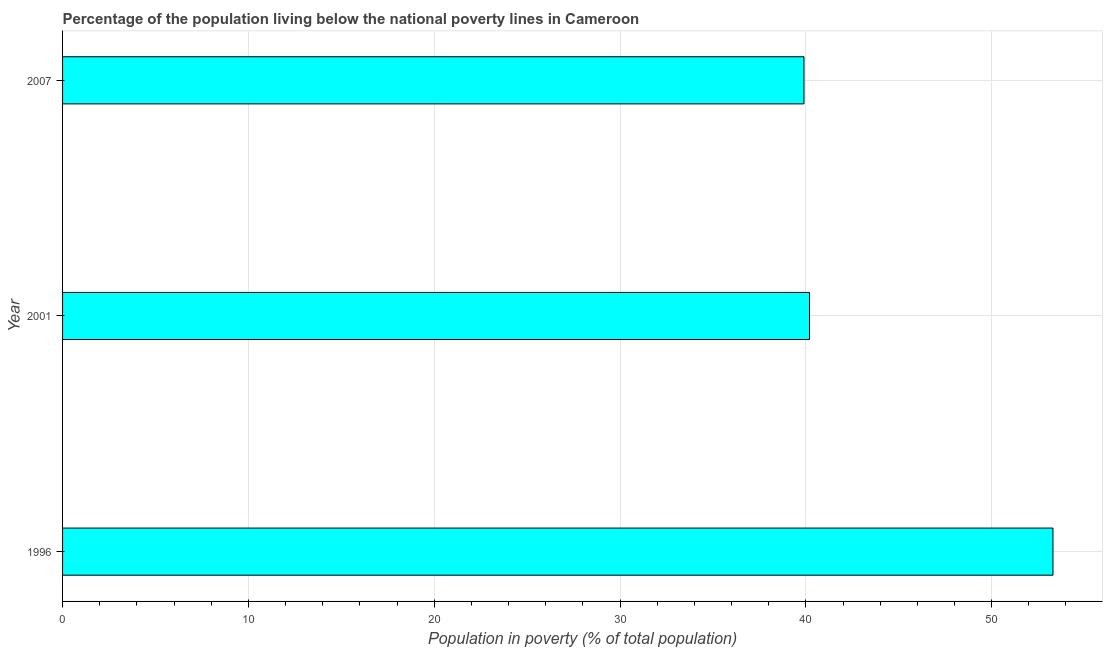Does the graph contain grids?
Offer a terse response. Yes. What is the title of the graph?
Give a very brief answer. Percentage of the population living below the national poverty lines in Cameroon. What is the label or title of the X-axis?
Provide a succinct answer. Population in poverty (% of total population). What is the label or title of the Y-axis?
Your answer should be very brief. Year. What is the percentage of population living below poverty line in 1996?
Your response must be concise. 53.3. Across all years, what is the maximum percentage of population living below poverty line?
Your answer should be very brief. 53.3. Across all years, what is the minimum percentage of population living below poverty line?
Keep it short and to the point. 39.9. In which year was the percentage of population living below poverty line minimum?
Make the answer very short. 2007. What is the sum of the percentage of population living below poverty line?
Give a very brief answer. 133.4. What is the average percentage of population living below poverty line per year?
Offer a terse response. 44.47. What is the median percentage of population living below poverty line?
Your response must be concise. 40.2. In how many years, is the percentage of population living below poverty line greater than 40 %?
Provide a succinct answer. 2. Do a majority of the years between 2001 and 2007 (inclusive) have percentage of population living below poverty line greater than 44 %?
Keep it short and to the point. No. Is the difference between the percentage of population living below poverty line in 2001 and 2007 greater than the difference between any two years?
Give a very brief answer. No. What is the difference between the highest and the second highest percentage of population living below poverty line?
Offer a very short reply. 13.1. Is the sum of the percentage of population living below poverty line in 1996 and 2007 greater than the maximum percentage of population living below poverty line across all years?
Keep it short and to the point. Yes. What is the difference between the highest and the lowest percentage of population living below poverty line?
Your answer should be compact. 13.4. In how many years, is the percentage of population living below poverty line greater than the average percentage of population living below poverty line taken over all years?
Provide a short and direct response. 1. How many years are there in the graph?
Provide a succinct answer. 3. What is the difference between two consecutive major ticks on the X-axis?
Make the answer very short. 10. Are the values on the major ticks of X-axis written in scientific E-notation?
Keep it short and to the point. No. What is the Population in poverty (% of total population) in 1996?
Your response must be concise. 53.3. What is the Population in poverty (% of total population) of 2001?
Keep it short and to the point. 40.2. What is the Population in poverty (% of total population) of 2007?
Your response must be concise. 39.9. What is the difference between the Population in poverty (% of total population) in 2001 and 2007?
Offer a terse response. 0.3. What is the ratio of the Population in poverty (% of total population) in 1996 to that in 2001?
Provide a short and direct response. 1.33. What is the ratio of the Population in poverty (% of total population) in 1996 to that in 2007?
Provide a succinct answer. 1.34. 